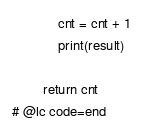<code> <loc_0><loc_0><loc_500><loc_500><_Python_>            cnt = cnt + 1
            print(result)

        return cnt
# @lc code=end

</code> 